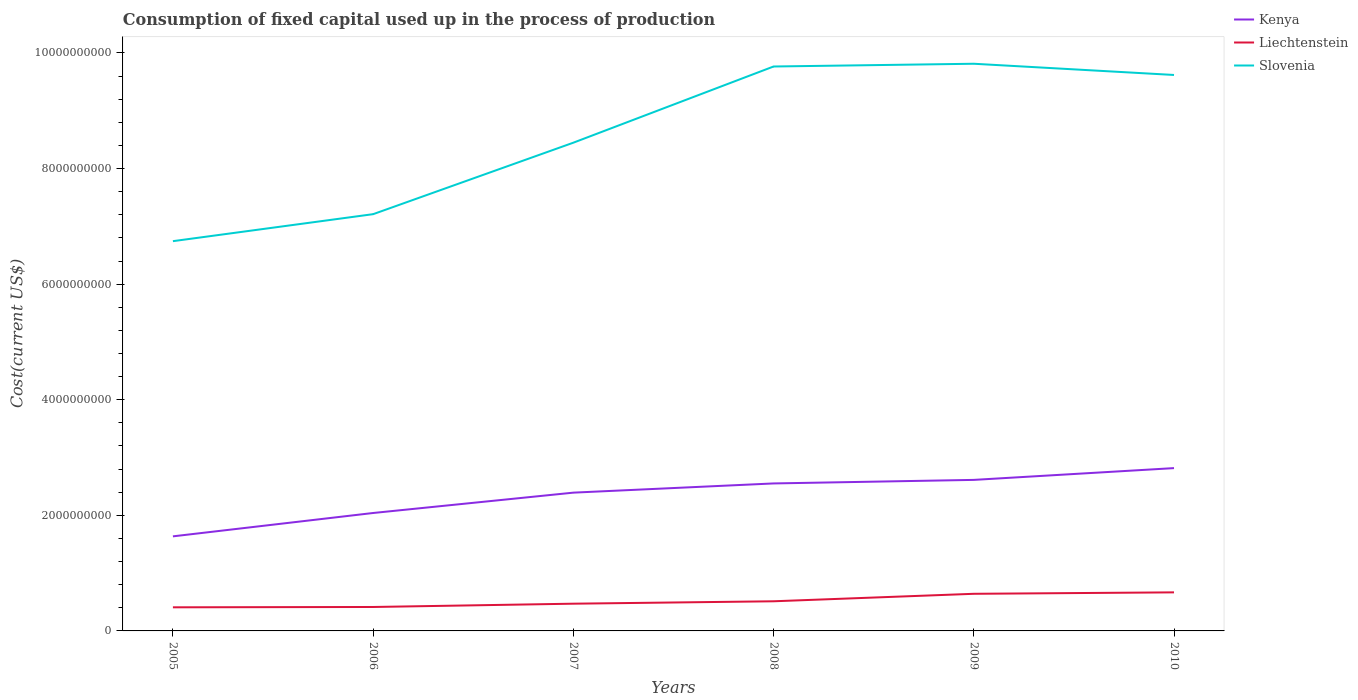Across all years, what is the maximum amount consumed in the process of production in Slovenia?
Your answer should be compact. 6.74e+09. In which year was the amount consumed in the process of production in Slovenia maximum?
Offer a terse response. 2005. What is the total amount consumed in the process of production in Slovenia in the graph?
Your answer should be compact. -2.56e+09. What is the difference between the highest and the second highest amount consumed in the process of production in Slovenia?
Keep it short and to the point. 3.07e+09. What is the difference between the highest and the lowest amount consumed in the process of production in Kenya?
Keep it short and to the point. 4. How many lines are there?
Keep it short and to the point. 3. How many years are there in the graph?
Keep it short and to the point. 6. What is the difference between two consecutive major ticks on the Y-axis?
Offer a very short reply. 2.00e+09. Are the values on the major ticks of Y-axis written in scientific E-notation?
Keep it short and to the point. No. Does the graph contain any zero values?
Give a very brief answer. No. Does the graph contain grids?
Provide a short and direct response. No. Where does the legend appear in the graph?
Provide a succinct answer. Top right. What is the title of the graph?
Your answer should be very brief. Consumption of fixed capital used up in the process of production. Does "Low income" appear as one of the legend labels in the graph?
Provide a succinct answer. No. What is the label or title of the X-axis?
Provide a short and direct response. Years. What is the label or title of the Y-axis?
Your answer should be very brief. Cost(current US$). What is the Cost(current US$) in Kenya in 2005?
Offer a terse response. 1.64e+09. What is the Cost(current US$) of Liechtenstein in 2005?
Give a very brief answer. 4.09e+08. What is the Cost(current US$) of Slovenia in 2005?
Offer a very short reply. 6.74e+09. What is the Cost(current US$) in Kenya in 2006?
Give a very brief answer. 2.04e+09. What is the Cost(current US$) of Liechtenstein in 2006?
Keep it short and to the point. 4.14e+08. What is the Cost(current US$) of Slovenia in 2006?
Your answer should be compact. 7.21e+09. What is the Cost(current US$) of Kenya in 2007?
Your answer should be compact. 2.39e+09. What is the Cost(current US$) of Liechtenstein in 2007?
Keep it short and to the point. 4.71e+08. What is the Cost(current US$) of Slovenia in 2007?
Make the answer very short. 8.45e+09. What is the Cost(current US$) of Kenya in 2008?
Make the answer very short. 2.55e+09. What is the Cost(current US$) in Liechtenstein in 2008?
Provide a succinct answer. 5.13e+08. What is the Cost(current US$) in Slovenia in 2008?
Keep it short and to the point. 9.77e+09. What is the Cost(current US$) of Kenya in 2009?
Your answer should be compact. 2.61e+09. What is the Cost(current US$) of Liechtenstein in 2009?
Provide a short and direct response. 6.42e+08. What is the Cost(current US$) of Slovenia in 2009?
Your response must be concise. 9.81e+09. What is the Cost(current US$) of Kenya in 2010?
Provide a succinct answer. 2.82e+09. What is the Cost(current US$) of Liechtenstein in 2010?
Offer a very short reply. 6.67e+08. What is the Cost(current US$) of Slovenia in 2010?
Provide a succinct answer. 9.62e+09. Across all years, what is the maximum Cost(current US$) in Kenya?
Your response must be concise. 2.82e+09. Across all years, what is the maximum Cost(current US$) of Liechtenstein?
Provide a short and direct response. 6.67e+08. Across all years, what is the maximum Cost(current US$) of Slovenia?
Your answer should be compact. 9.81e+09. Across all years, what is the minimum Cost(current US$) in Kenya?
Give a very brief answer. 1.64e+09. Across all years, what is the minimum Cost(current US$) of Liechtenstein?
Your answer should be compact. 4.09e+08. Across all years, what is the minimum Cost(current US$) of Slovenia?
Keep it short and to the point. 6.74e+09. What is the total Cost(current US$) in Kenya in the graph?
Offer a terse response. 1.41e+1. What is the total Cost(current US$) of Liechtenstein in the graph?
Ensure brevity in your answer.  3.12e+09. What is the total Cost(current US$) of Slovenia in the graph?
Ensure brevity in your answer.  5.16e+1. What is the difference between the Cost(current US$) of Kenya in 2005 and that in 2006?
Give a very brief answer. -4.04e+08. What is the difference between the Cost(current US$) in Liechtenstein in 2005 and that in 2006?
Provide a succinct answer. -5.47e+06. What is the difference between the Cost(current US$) of Slovenia in 2005 and that in 2006?
Offer a very short reply. -4.67e+08. What is the difference between the Cost(current US$) of Kenya in 2005 and that in 2007?
Offer a terse response. -7.56e+08. What is the difference between the Cost(current US$) in Liechtenstein in 2005 and that in 2007?
Provide a succinct answer. -6.26e+07. What is the difference between the Cost(current US$) of Slovenia in 2005 and that in 2007?
Keep it short and to the point. -1.70e+09. What is the difference between the Cost(current US$) in Kenya in 2005 and that in 2008?
Make the answer very short. -9.16e+08. What is the difference between the Cost(current US$) in Liechtenstein in 2005 and that in 2008?
Your answer should be very brief. -1.04e+08. What is the difference between the Cost(current US$) of Slovenia in 2005 and that in 2008?
Offer a very short reply. -3.02e+09. What is the difference between the Cost(current US$) in Kenya in 2005 and that in 2009?
Give a very brief answer. -9.77e+08. What is the difference between the Cost(current US$) in Liechtenstein in 2005 and that in 2009?
Provide a succinct answer. -2.34e+08. What is the difference between the Cost(current US$) of Slovenia in 2005 and that in 2009?
Give a very brief answer. -3.07e+09. What is the difference between the Cost(current US$) of Kenya in 2005 and that in 2010?
Provide a succinct answer. -1.18e+09. What is the difference between the Cost(current US$) of Liechtenstein in 2005 and that in 2010?
Provide a succinct answer. -2.59e+08. What is the difference between the Cost(current US$) of Slovenia in 2005 and that in 2010?
Give a very brief answer. -2.88e+09. What is the difference between the Cost(current US$) in Kenya in 2006 and that in 2007?
Provide a short and direct response. -3.52e+08. What is the difference between the Cost(current US$) in Liechtenstein in 2006 and that in 2007?
Your answer should be compact. -5.71e+07. What is the difference between the Cost(current US$) of Slovenia in 2006 and that in 2007?
Make the answer very short. -1.24e+09. What is the difference between the Cost(current US$) in Kenya in 2006 and that in 2008?
Offer a terse response. -5.11e+08. What is the difference between the Cost(current US$) of Liechtenstein in 2006 and that in 2008?
Offer a terse response. -9.88e+07. What is the difference between the Cost(current US$) in Slovenia in 2006 and that in 2008?
Give a very brief answer. -2.56e+09. What is the difference between the Cost(current US$) of Kenya in 2006 and that in 2009?
Provide a short and direct response. -5.73e+08. What is the difference between the Cost(current US$) of Liechtenstein in 2006 and that in 2009?
Offer a terse response. -2.28e+08. What is the difference between the Cost(current US$) of Slovenia in 2006 and that in 2009?
Your response must be concise. -2.60e+09. What is the difference between the Cost(current US$) in Kenya in 2006 and that in 2010?
Your response must be concise. -7.77e+08. What is the difference between the Cost(current US$) in Liechtenstein in 2006 and that in 2010?
Your response must be concise. -2.53e+08. What is the difference between the Cost(current US$) in Slovenia in 2006 and that in 2010?
Provide a short and direct response. -2.41e+09. What is the difference between the Cost(current US$) of Kenya in 2007 and that in 2008?
Offer a very short reply. -1.59e+08. What is the difference between the Cost(current US$) in Liechtenstein in 2007 and that in 2008?
Your answer should be compact. -4.17e+07. What is the difference between the Cost(current US$) of Slovenia in 2007 and that in 2008?
Your response must be concise. -1.32e+09. What is the difference between the Cost(current US$) in Kenya in 2007 and that in 2009?
Offer a terse response. -2.21e+08. What is the difference between the Cost(current US$) in Liechtenstein in 2007 and that in 2009?
Make the answer very short. -1.71e+08. What is the difference between the Cost(current US$) of Slovenia in 2007 and that in 2009?
Provide a succinct answer. -1.37e+09. What is the difference between the Cost(current US$) in Kenya in 2007 and that in 2010?
Provide a short and direct response. -4.25e+08. What is the difference between the Cost(current US$) in Liechtenstein in 2007 and that in 2010?
Provide a short and direct response. -1.96e+08. What is the difference between the Cost(current US$) of Slovenia in 2007 and that in 2010?
Provide a short and direct response. -1.17e+09. What is the difference between the Cost(current US$) of Kenya in 2008 and that in 2009?
Provide a succinct answer. -6.15e+07. What is the difference between the Cost(current US$) of Liechtenstein in 2008 and that in 2009?
Give a very brief answer. -1.29e+08. What is the difference between the Cost(current US$) of Slovenia in 2008 and that in 2009?
Your answer should be compact. -4.76e+07. What is the difference between the Cost(current US$) in Kenya in 2008 and that in 2010?
Give a very brief answer. -2.65e+08. What is the difference between the Cost(current US$) in Liechtenstein in 2008 and that in 2010?
Keep it short and to the point. -1.54e+08. What is the difference between the Cost(current US$) of Slovenia in 2008 and that in 2010?
Ensure brevity in your answer.  1.47e+08. What is the difference between the Cost(current US$) of Kenya in 2009 and that in 2010?
Provide a succinct answer. -2.04e+08. What is the difference between the Cost(current US$) in Liechtenstein in 2009 and that in 2010?
Keep it short and to the point. -2.50e+07. What is the difference between the Cost(current US$) of Slovenia in 2009 and that in 2010?
Offer a very short reply. 1.94e+08. What is the difference between the Cost(current US$) in Kenya in 2005 and the Cost(current US$) in Liechtenstein in 2006?
Provide a short and direct response. 1.22e+09. What is the difference between the Cost(current US$) in Kenya in 2005 and the Cost(current US$) in Slovenia in 2006?
Ensure brevity in your answer.  -5.57e+09. What is the difference between the Cost(current US$) of Liechtenstein in 2005 and the Cost(current US$) of Slovenia in 2006?
Your answer should be very brief. -6.80e+09. What is the difference between the Cost(current US$) of Kenya in 2005 and the Cost(current US$) of Liechtenstein in 2007?
Your answer should be very brief. 1.17e+09. What is the difference between the Cost(current US$) of Kenya in 2005 and the Cost(current US$) of Slovenia in 2007?
Keep it short and to the point. -6.81e+09. What is the difference between the Cost(current US$) in Liechtenstein in 2005 and the Cost(current US$) in Slovenia in 2007?
Keep it short and to the point. -8.04e+09. What is the difference between the Cost(current US$) in Kenya in 2005 and the Cost(current US$) in Liechtenstein in 2008?
Provide a short and direct response. 1.12e+09. What is the difference between the Cost(current US$) in Kenya in 2005 and the Cost(current US$) in Slovenia in 2008?
Ensure brevity in your answer.  -8.13e+09. What is the difference between the Cost(current US$) in Liechtenstein in 2005 and the Cost(current US$) in Slovenia in 2008?
Make the answer very short. -9.36e+09. What is the difference between the Cost(current US$) of Kenya in 2005 and the Cost(current US$) of Liechtenstein in 2009?
Provide a short and direct response. 9.94e+08. What is the difference between the Cost(current US$) in Kenya in 2005 and the Cost(current US$) in Slovenia in 2009?
Offer a terse response. -8.18e+09. What is the difference between the Cost(current US$) of Liechtenstein in 2005 and the Cost(current US$) of Slovenia in 2009?
Keep it short and to the point. -9.40e+09. What is the difference between the Cost(current US$) of Kenya in 2005 and the Cost(current US$) of Liechtenstein in 2010?
Make the answer very short. 9.69e+08. What is the difference between the Cost(current US$) of Kenya in 2005 and the Cost(current US$) of Slovenia in 2010?
Your answer should be very brief. -7.98e+09. What is the difference between the Cost(current US$) of Liechtenstein in 2005 and the Cost(current US$) of Slovenia in 2010?
Provide a short and direct response. -9.21e+09. What is the difference between the Cost(current US$) of Kenya in 2006 and the Cost(current US$) of Liechtenstein in 2007?
Offer a terse response. 1.57e+09. What is the difference between the Cost(current US$) in Kenya in 2006 and the Cost(current US$) in Slovenia in 2007?
Keep it short and to the point. -6.41e+09. What is the difference between the Cost(current US$) of Liechtenstein in 2006 and the Cost(current US$) of Slovenia in 2007?
Provide a succinct answer. -8.03e+09. What is the difference between the Cost(current US$) in Kenya in 2006 and the Cost(current US$) in Liechtenstein in 2008?
Offer a very short reply. 1.53e+09. What is the difference between the Cost(current US$) in Kenya in 2006 and the Cost(current US$) in Slovenia in 2008?
Keep it short and to the point. -7.73e+09. What is the difference between the Cost(current US$) of Liechtenstein in 2006 and the Cost(current US$) of Slovenia in 2008?
Provide a succinct answer. -9.35e+09. What is the difference between the Cost(current US$) of Kenya in 2006 and the Cost(current US$) of Liechtenstein in 2009?
Make the answer very short. 1.40e+09. What is the difference between the Cost(current US$) of Kenya in 2006 and the Cost(current US$) of Slovenia in 2009?
Provide a succinct answer. -7.77e+09. What is the difference between the Cost(current US$) in Liechtenstein in 2006 and the Cost(current US$) in Slovenia in 2009?
Offer a terse response. -9.40e+09. What is the difference between the Cost(current US$) in Kenya in 2006 and the Cost(current US$) in Liechtenstein in 2010?
Give a very brief answer. 1.37e+09. What is the difference between the Cost(current US$) in Kenya in 2006 and the Cost(current US$) in Slovenia in 2010?
Provide a succinct answer. -7.58e+09. What is the difference between the Cost(current US$) in Liechtenstein in 2006 and the Cost(current US$) in Slovenia in 2010?
Provide a succinct answer. -9.21e+09. What is the difference between the Cost(current US$) in Kenya in 2007 and the Cost(current US$) in Liechtenstein in 2008?
Offer a terse response. 1.88e+09. What is the difference between the Cost(current US$) in Kenya in 2007 and the Cost(current US$) in Slovenia in 2008?
Provide a short and direct response. -7.37e+09. What is the difference between the Cost(current US$) of Liechtenstein in 2007 and the Cost(current US$) of Slovenia in 2008?
Ensure brevity in your answer.  -9.29e+09. What is the difference between the Cost(current US$) of Kenya in 2007 and the Cost(current US$) of Liechtenstein in 2009?
Offer a very short reply. 1.75e+09. What is the difference between the Cost(current US$) of Kenya in 2007 and the Cost(current US$) of Slovenia in 2009?
Give a very brief answer. -7.42e+09. What is the difference between the Cost(current US$) in Liechtenstein in 2007 and the Cost(current US$) in Slovenia in 2009?
Your answer should be compact. -9.34e+09. What is the difference between the Cost(current US$) in Kenya in 2007 and the Cost(current US$) in Liechtenstein in 2010?
Make the answer very short. 1.73e+09. What is the difference between the Cost(current US$) of Kenya in 2007 and the Cost(current US$) of Slovenia in 2010?
Offer a very short reply. -7.23e+09. What is the difference between the Cost(current US$) in Liechtenstein in 2007 and the Cost(current US$) in Slovenia in 2010?
Keep it short and to the point. -9.15e+09. What is the difference between the Cost(current US$) in Kenya in 2008 and the Cost(current US$) in Liechtenstein in 2009?
Ensure brevity in your answer.  1.91e+09. What is the difference between the Cost(current US$) in Kenya in 2008 and the Cost(current US$) in Slovenia in 2009?
Provide a succinct answer. -7.26e+09. What is the difference between the Cost(current US$) of Liechtenstein in 2008 and the Cost(current US$) of Slovenia in 2009?
Offer a very short reply. -9.30e+09. What is the difference between the Cost(current US$) of Kenya in 2008 and the Cost(current US$) of Liechtenstein in 2010?
Give a very brief answer. 1.88e+09. What is the difference between the Cost(current US$) of Kenya in 2008 and the Cost(current US$) of Slovenia in 2010?
Give a very brief answer. -7.07e+09. What is the difference between the Cost(current US$) of Liechtenstein in 2008 and the Cost(current US$) of Slovenia in 2010?
Your response must be concise. -9.11e+09. What is the difference between the Cost(current US$) of Kenya in 2009 and the Cost(current US$) of Liechtenstein in 2010?
Your answer should be very brief. 1.95e+09. What is the difference between the Cost(current US$) in Kenya in 2009 and the Cost(current US$) in Slovenia in 2010?
Make the answer very short. -7.01e+09. What is the difference between the Cost(current US$) of Liechtenstein in 2009 and the Cost(current US$) of Slovenia in 2010?
Your answer should be compact. -8.98e+09. What is the average Cost(current US$) in Kenya per year?
Your response must be concise. 2.34e+09. What is the average Cost(current US$) in Liechtenstein per year?
Your response must be concise. 5.19e+08. What is the average Cost(current US$) of Slovenia per year?
Keep it short and to the point. 8.60e+09. In the year 2005, what is the difference between the Cost(current US$) in Kenya and Cost(current US$) in Liechtenstein?
Your response must be concise. 1.23e+09. In the year 2005, what is the difference between the Cost(current US$) of Kenya and Cost(current US$) of Slovenia?
Provide a succinct answer. -5.11e+09. In the year 2005, what is the difference between the Cost(current US$) of Liechtenstein and Cost(current US$) of Slovenia?
Give a very brief answer. -6.34e+09. In the year 2006, what is the difference between the Cost(current US$) in Kenya and Cost(current US$) in Liechtenstein?
Give a very brief answer. 1.63e+09. In the year 2006, what is the difference between the Cost(current US$) in Kenya and Cost(current US$) in Slovenia?
Provide a succinct answer. -5.17e+09. In the year 2006, what is the difference between the Cost(current US$) in Liechtenstein and Cost(current US$) in Slovenia?
Provide a succinct answer. -6.80e+09. In the year 2007, what is the difference between the Cost(current US$) of Kenya and Cost(current US$) of Liechtenstein?
Offer a very short reply. 1.92e+09. In the year 2007, what is the difference between the Cost(current US$) in Kenya and Cost(current US$) in Slovenia?
Ensure brevity in your answer.  -6.06e+09. In the year 2007, what is the difference between the Cost(current US$) of Liechtenstein and Cost(current US$) of Slovenia?
Keep it short and to the point. -7.98e+09. In the year 2008, what is the difference between the Cost(current US$) of Kenya and Cost(current US$) of Liechtenstein?
Provide a short and direct response. 2.04e+09. In the year 2008, what is the difference between the Cost(current US$) of Kenya and Cost(current US$) of Slovenia?
Your answer should be compact. -7.21e+09. In the year 2008, what is the difference between the Cost(current US$) of Liechtenstein and Cost(current US$) of Slovenia?
Make the answer very short. -9.25e+09. In the year 2009, what is the difference between the Cost(current US$) of Kenya and Cost(current US$) of Liechtenstein?
Your answer should be compact. 1.97e+09. In the year 2009, what is the difference between the Cost(current US$) in Kenya and Cost(current US$) in Slovenia?
Your answer should be compact. -7.20e+09. In the year 2009, what is the difference between the Cost(current US$) in Liechtenstein and Cost(current US$) in Slovenia?
Ensure brevity in your answer.  -9.17e+09. In the year 2010, what is the difference between the Cost(current US$) in Kenya and Cost(current US$) in Liechtenstein?
Offer a terse response. 2.15e+09. In the year 2010, what is the difference between the Cost(current US$) of Kenya and Cost(current US$) of Slovenia?
Ensure brevity in your answer.  -6.80e+09. In the year 2010, what is the difference between the Cost(current US$) in Liechtenstein and Cost(current US$) in Slovenia?
Provide a short and direct response. -8.95e+09. What is the ratio of the Cost(current US$) of Kenya in 2005 to that in 2006?
Make the answer very short. 0.8. What is the ratio of the Cost(current US$) of Liechtenstein in 2005 to that in 2006?
Provide a succinct answer. 0.99. What is the ratio of the Cost(current US$) in Slovenia in 2005 to that in 2006?
Your answer should be compact. 0.94. What is the ratio of the Cost(current US$) in Kenya in 2005 to that in 2007?
Ensure brevity in your answer.  0.68. What is the ratio of the Cost(current US$) of Liechtenstein in 2005 to that in 2007?
Offer a very short reply. 0.87. What is the ratio of the Cost(current US$) of Slovenia in 2005 to that in 2007?
Your answer should be very brief. 0.8. What is the ratio of the Cost(current US$) of Kenya in 2005 to that in 2008?
Your response must be concise. 0.64. What is the ratio of the Cost(current US$) of Liechtenstein in 2005 to that in 2008?
Provide a short and direct response. 0.8. What is the ratio of the Cost(current US$) of Slovenia in 2005 to that in 2008?
Make the answer very short. 0.69. What is the ratio of the Cost(current US$) in Kenya in 2005 to that in 2009?
Offer a very short reply. 0.63. What is the ratio of the Cost(current US$) of Liechtenstein in 2005 to that in 2009?
Provide a succinct answer. 0.64. What is the ratio of the Cost(current US$) of Slovenia in 2005 to that in 2009?
Give a very brief answer. 0.69. What is the ratio of the Cost(current US$) in Kenya in 2005 to that in 2010?
Make the answer very short. 0.58. What is the ratio of the Cost(current US$) in Liechtenstein in 2005 to that in 2010?
Your answer should be very brief. 0.61. What is the ratio of the Cost(current US$) in Slovenia in 2005 to that in 2010?
Provide a succinct answer. 0.7. What is the ratio of the Cost(current US$) in Kenya in 2006 to that in 2007?
Make the answer very short. 0.85. What is the ratio of the Cost(current US$) in Liechtenstein in 2006 to that in 2007?
Ensure brevity in your answer.  0.88. What is the ratio of the Cost(current US$) of Slovenia in 2006 to that in 2007?
Give a very brief answer. 0.85. What is the ratio of the Cost(current US$) of Kenya in 2006 to that in 2008?
Provide a short and direct response. 0.8. What is the ratio of the Cost(current US$) in Liechtenstein in 2006 to that in 2008?
Your answer should be very brief. 0.81. What is the ratio of the Cost(current US$) of Slovenia in 2006 to that in 2008?
Your answer should be compact. 0.74. What is the ratio of the Cost(current US$) in Kenya in 2006 to that in 2009?
Your response must be concise. 0.78. What is the ratio of the Cost(current US$) in Liechtenstein in 2006 to that in 2009?
Keep it short and to the point. 0.64. What is the ratio of the Cost(current US$) in Slovenia in 2006 to that in 2009?
Provide a short and direct response. 0.73. What is the ratio of the Cost(current US$) of Kenya in 2006 to that in 2010?
Give a very brief answer. 0.72. What is the ratio of the Cost(current US$) in Liechtenstein in 2006 to that in 2010?
Your response must be concise. 0.62. What is the ratio of the Cost(current US$) of Slovenia in 2006 to that in 2010?
Keep it short and to the point. 0.75. What is the ratio of the Cost(current US$) in Kenya in 2007 to that in 2008?
Your answer should be compact. 0.94. What is the ratio of the Cost(current US$) in Liechtenstein in 2007 to that in 2008?
Ensure brevity in your answer.  0.92. What is the ratio of the Cost(current US$) of Slovenia in 2007 to that in 2008?
Provide a short and direct response. 0.86. What is the ratio of the Cost(current US$) in Kenya in 2007 to that in 2009?
Your answer should be compact. 0.92. What is the ratio of the Cost(current US$) of Liechtenstein in 2007 to that in 2009?
Provide a succinct answer. 0.73. What is the ratio of the Cost(current US$) of Slovenia in 2007 to that in 2009?
Offer a very short reply. 0.86. What is the ratio of the Cost(current US$) of Kenya in 2007 to that in 2010?
Make the answer very short. 0.85. What is the ratio of the Cost(current US$) in Liechtenstein in 2007 to that in 2010?
Your answer should be compact. 0.71. What is the ratio of the Cost(current US$) in Slovenia in 2007 to that in 2010?
Give a very brief answer. 0.88. What is the ratio of the Cost(current US$) in Kenya in 2008 to that in 2009?
Give a very brief answer. 0.98. What is the ratio of the Cost(current US$) of Liechtenstein in 2008 to that in 2009?
Offer a terse response. 0.8. What is the ratio of the Cost(current US$) of Kenya in 2008 to that in 2010?
Give a very brief answer. 0.91. What is the ratio of the Cost(current US$) in Liechtenstein in 2008 to that in 2010?
Make the answer very short. 0.77. What is the ratio of the Cost(current US$) in Slovenia in 2008 to that in 2010?
Make the answer very short. 1.02. What is the ratio of the Cost(current US$) of Kenya in 2009 to that in 2010?
Make the answer very short. 0.93. What is the ratio of the Cost(current US$) in Liechtenstein in 2009 to that in 2010?
Offer a terse response. 0.96. What is the ratio of the Cost(current US$) of Slovenia in 2009 to that in 2010?
Offer a very short reply. 1.02. What is the difference between the highest and the second highest Cost(current US$) in Kenya?
Make the answer very short. 2.04e+08. What is the difference between the highest and the second highest Cost(current US$) in Liechtenstein?
Provide a succinct answer. 2.50e+07. What is the difference between the highest and the second highest Cost(current US$) in Slovenia?
Provide a succinct answer. 4.76e+07. What is the difference between the highest and the lowest Cost(current US$) of Kenya?
Give a very brief answer. 1.18e+09. What is the difference between the highest and the lowest Cost(current US$) of Liechtenstein?
Provide a succinct answer. 2.59e+08. What is the difference between the highest and the lowest Cost(current US$) in Slovenia?
Your answer should be very brief. 3.07e+09. 